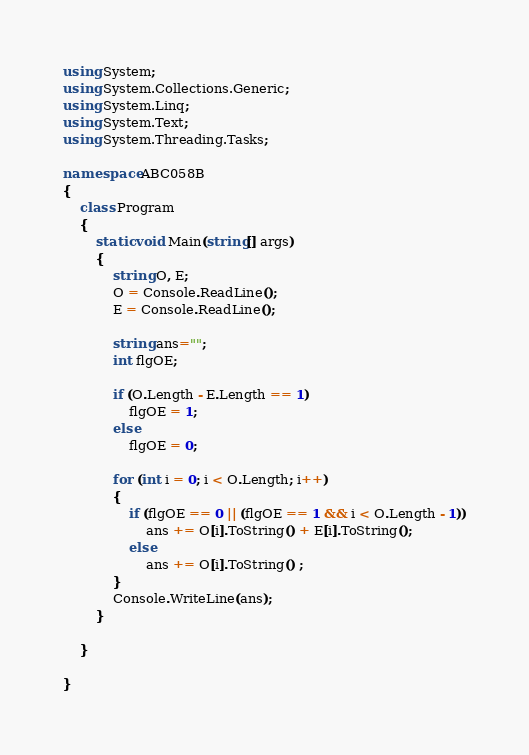Convert code to text. <code><loc_0><loc_0><loc_500><loc_500><_C#_>using System;
using System.Collections.Generic;
using System.Linq;
using System.Text;
using System.Threading.Tasks;

namespace ABC058B
{
    class Program
    {
        static void Main(string[] args)
        {
            string O, E;
            O = Console.ReadLine();
            E = Console.ReadLine();

            string ans="";
            int flgOE;

            if (O.Length - E.Length == 1)
                flgOE = 1;
            else
                flgOE = 0;

            for (int i = 0; i < O.Length; i++)
            {
                if (flgOE == 0 || (flgOE == 1 && i < O.Length - 1))
                    ans += O[i].ToString() + E[i].ToString();
                else
                    ans += O[i].ToString() ;
            }
            Console.WriteLine(ans);
        }

    }
    
}
</code> 